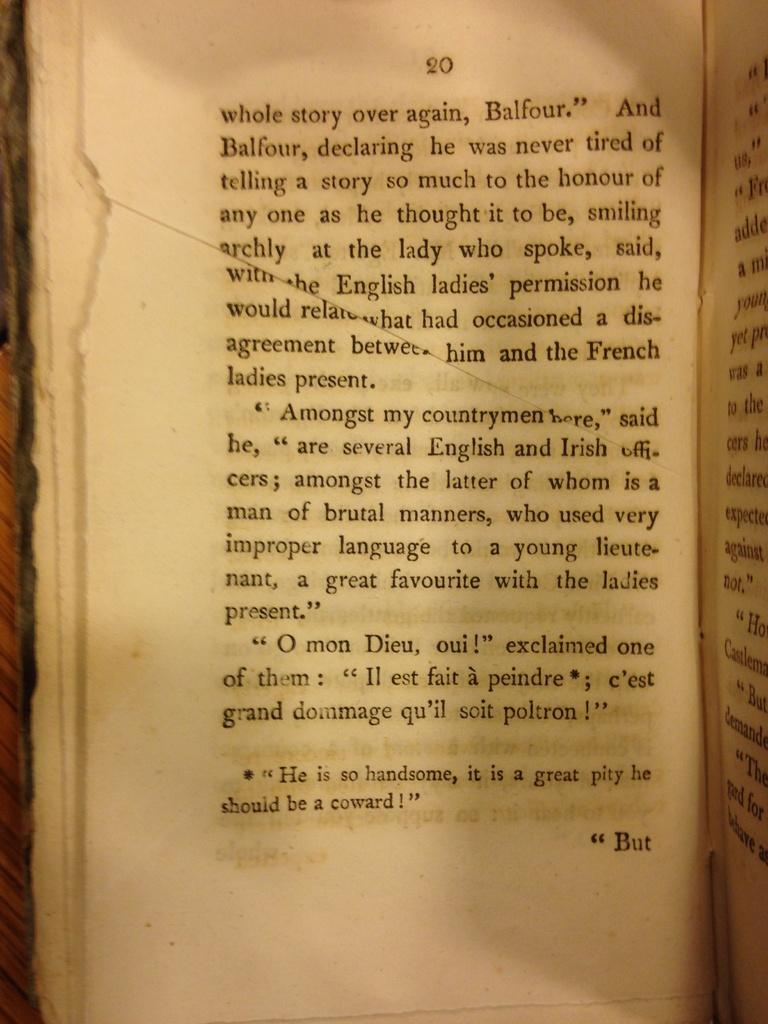What page is the book turned to?
Offer a terse response. 20. What is the first word on the page?
Offer a very short reply. Whole. 